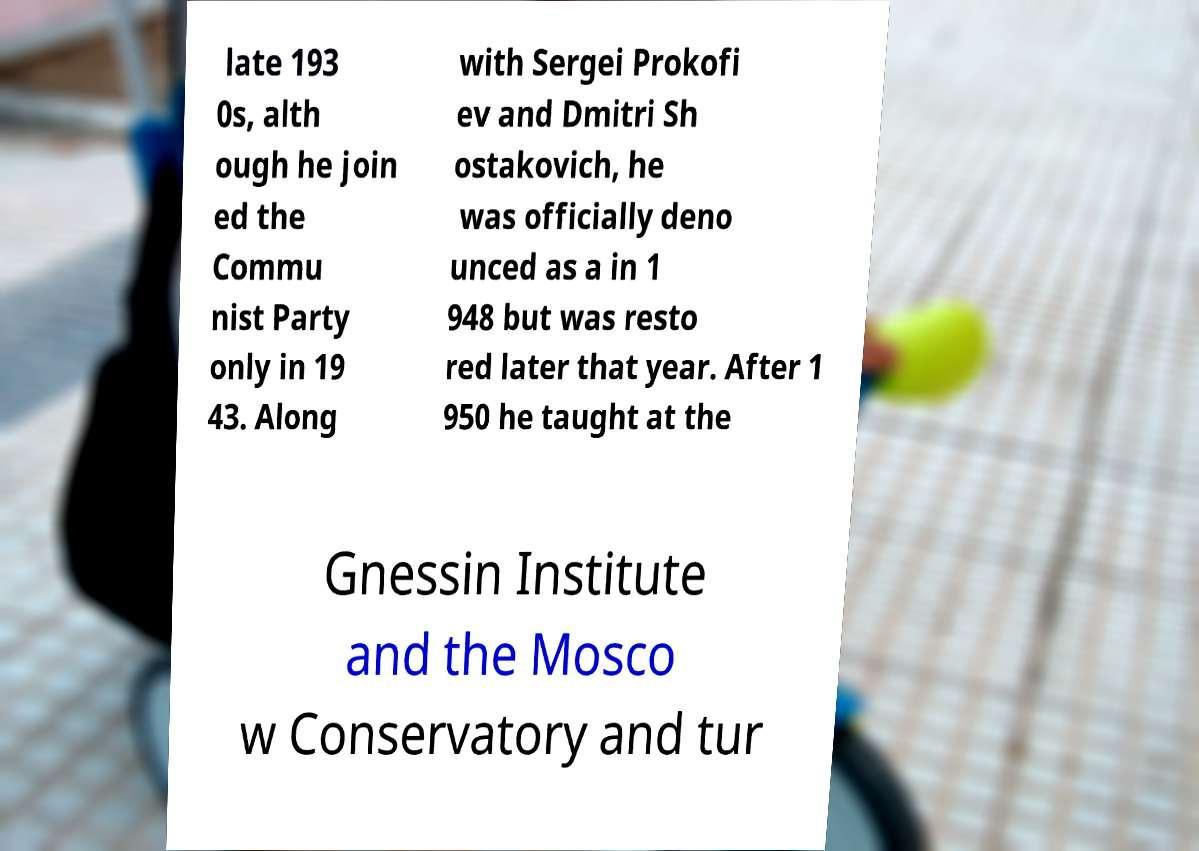For documentation purposes, I need the text within this image transcribed. Could you provide that? late 193 0s, alth ough he join ed the Commu nist Party only in 19 43. Along with Sergei Prokofi ev and Dmitri Sh ostakovich, he was officially deno unced as a in 1 948 but was resto red later that year. After 1 950 he taught at the Gnessin Institute and the Mosco w Conservatory and tur 